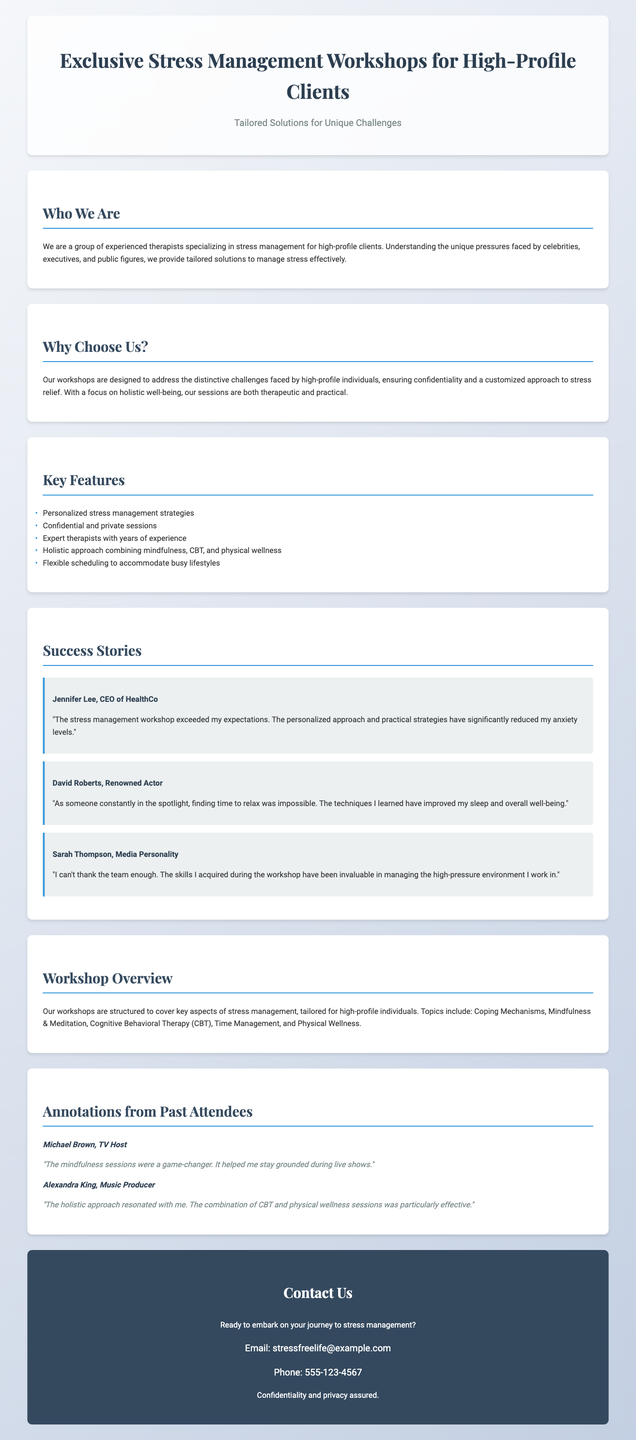What is the title of the workshops? The title of the workshops is presented prominently in the header of the document.
Answer: Exclusive Stress Management Workshops for High-Profile Clients Who are the targeted clients? The document specifies the focus of the workshops on a particular group of individuals.
Answer: High-profile clients What unique challenges do the workshops address? The document mentions the type of challenges that high-profile individuals typically face.
Answer: Unique pressures How many testimonials are provided? By counting the testimonials presented in the success stories section, we can determine the number.
Answer: Three What notable feature do the workshops guarantee? One of the key selling points mentioned in the document focuses on the assurance to clients.
Answer: Confidentiality Which therapy approaches are combined in the workshops? The document lists the approaches that are utilized within the workshop structure.
Answer: Mindfulness, CBT, and physical wellness Who is a testimonial from an actor? The document provides specific names associated with testimonials, identifying one from an acting profession.
Answer: David Roberts What feedback did Michael Brown provide? To answer this, we refer to the annotations section where attendees share their thoughts.
Answer: Mindfulness sessions were a game-changer What is the contact email for inquiries? The document has a section dedicated to contact information where the email is listed.
Answer: stressfreelife@example.com What are workshops designed to address? The workshops are aimed at addressing certain key aspects as stated in the workshop overview.
Answer: Stress management 